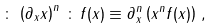Convert formula to latex. <formula><loc_0><loc_0><loc_500><loc_500>\colon \, \left ( \partial _ { x } x \right ) ^ { n } \, \colon \, f ( x ) \equiv \partial _ { x } ^ { n } \left ( x ^ { n } f ( x ) \right ) \, ,</formula> 